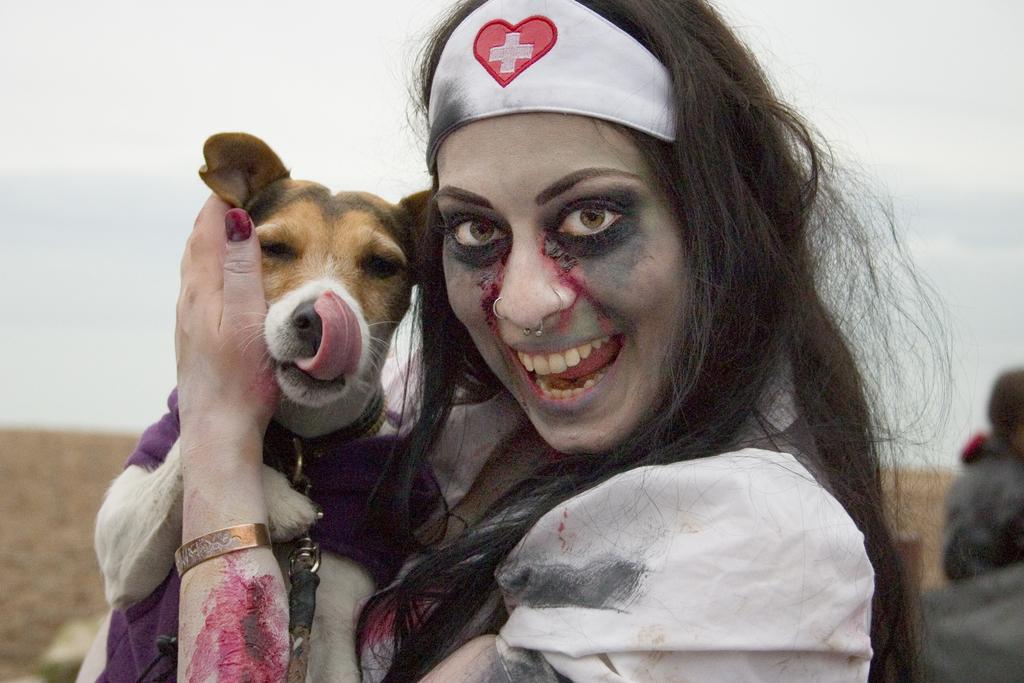In one or two sentences, can you explain what this image depicts? this picture shows a woman holding a dog in her hand and she wore a headband 